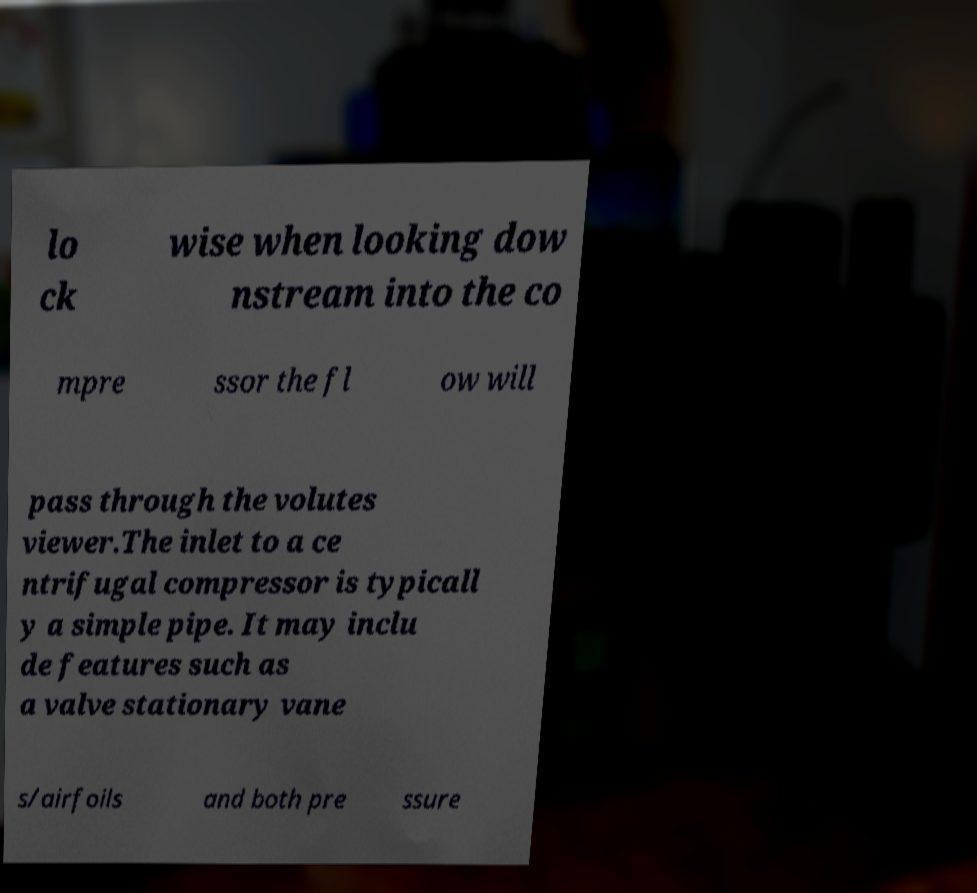Can you read and provide the text displayed in the image?This photo seems to have some interesting text. Can you extract and type it out for me? lo ck wise when looking dow nstream into the co mpre ssor the fl ow will pass through the volutes viewer.The inlet to a ce ntrifugal compressor is typicall y a simple pipe. It may inclu de features such as a valve stationary vane s/airfoils and both pre ssure 